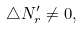<formula> <loc_0><loc_0><loc_500><loc_500>\bigtriangleup N _ { r } ^ { \prime } \neq 0 ,</formula> 